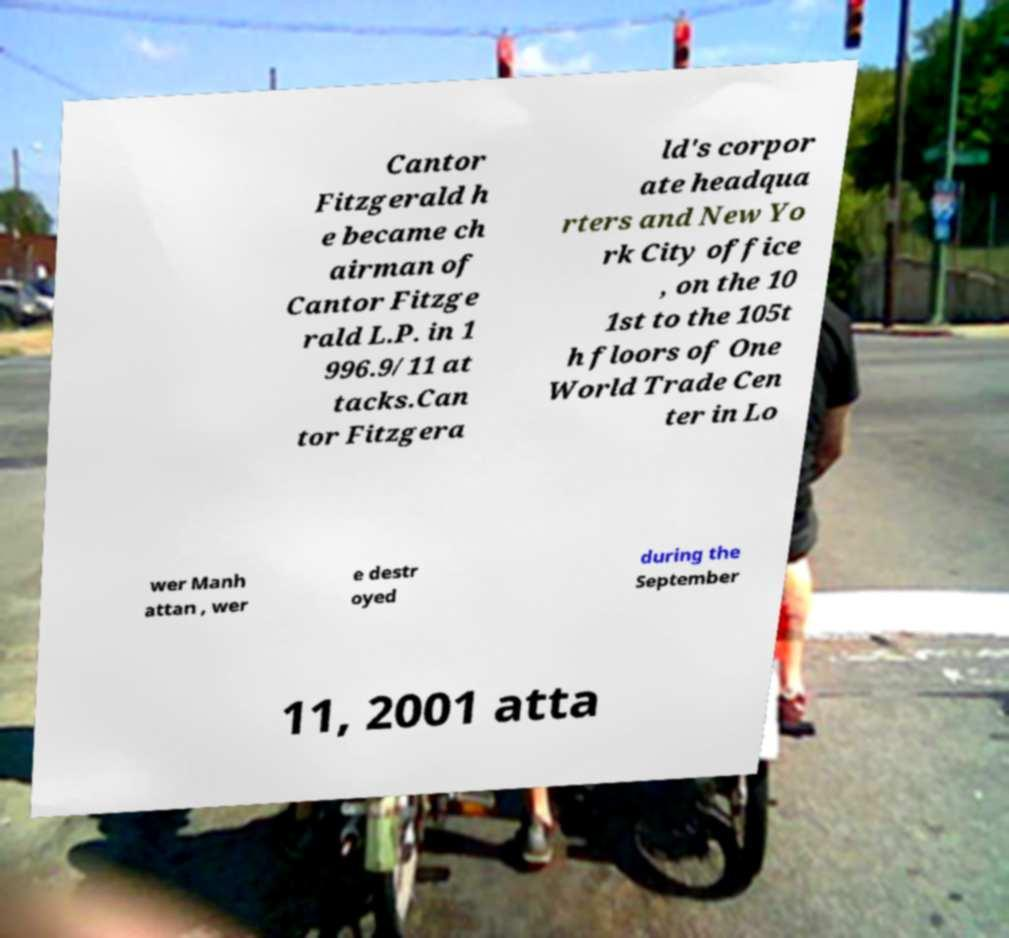For documentation purposes, I need the text within this image transcribed. Could you provide that? Cantor Fitzgerald h e became ch airman of Cantor Fitzge rald L.P. in 1 996.9/11 at tacks.Can tor Fitzgera ld's corpor ate headqua rters and New Yo rk City office , on the 10 1st to the 105t h floors of One World Trade Cen ter in Lo wer Manh attan , wer e destr oyed during the September 11, 2001 atta 